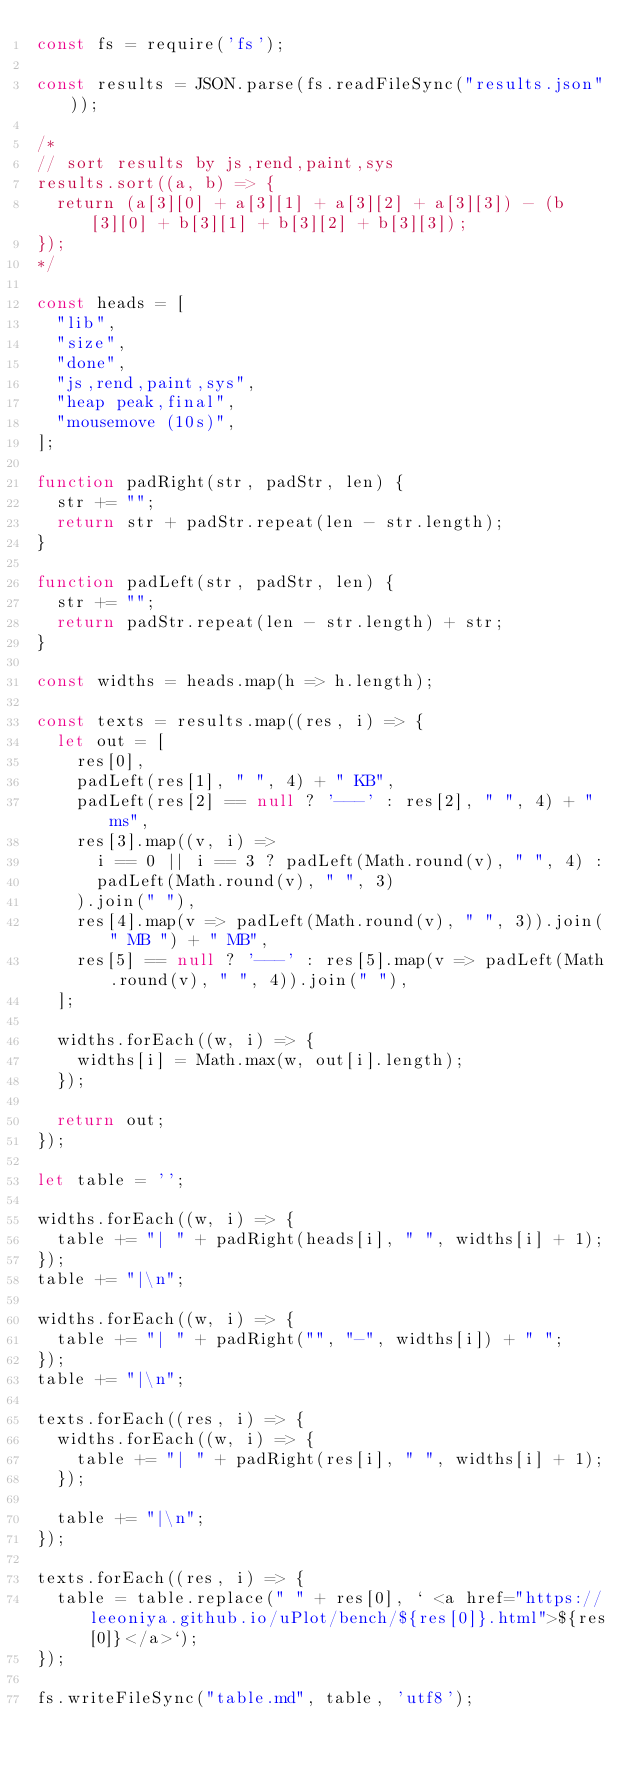Convert code to text. <code><loc_0><loc_0><loc_500><loc_500><_JavaScript_>const fs = require('fs');

const results = JSON.parse(fs.readFileSync("results.json"));

/*
// sort results by js,rend,paint,sys
results.sort((a, b) => {
	return (a[3][0] + a[3][1] + a[3][2] + a[3][3]) - (b[3][0] + b[3][1] + b[3][2] + b[3][3]);
});
*/

const heads = [
	"lib",
	"size",
	"done",
	"js,rend,paint,sys",
	"heap peak,final",
	"mousemove (10s)",
];

function padRight(str, padStr, len) {
	str += "";
	return str + padStr.repeat(len - str.length);
}

function padLeft(str, padStr, len) {
	str += "";
	return padStr.repeat(len - str.length) + str;
}

const widths = heads.map(h => h.length);

const texts = results.map((res, i) => {
	let out = [
		res[0],
		padLeft(res[1], " ", 4) + " KB",
		padLeft(res[2] == null ? '---' : res[2], " ", 4) + " ms",
		res[3].map((v, i) =>
			i == 0 || i == 3 ? padLeft(Math.round(v), " ", 4) :
			padLeft(Math.round(v), " ", 3)
		).join(" "),
		res[4].map(v => padLeft(Math.round(v), " ", 3)).join(" MB ") + " MB",
		res[5] == null ? '---' : res[5].map(v => padLeft(Math.round(v), " ", 4)).join(" "),
	];

	widths.forEach((w, i) => {
		widths[i] = Math.max(w, out[i].length);
	});

	return out;
});

let table = '';

widths.forEach((w, i) => {
	table += "| " + padRight(heads[i], " ", widths[i] + 1);
});
table += "|\n";

widths.forEach((w, i) => {
	table += "| " + padRight("", "-", widths[i]) + " ";
});
table += "|\n";

texts.forEach((res, i) => {
	widths.forEach((w, i) => {
		table += "| " + padRight(res[i], " ", widths[i] + 1);
	});

	table += "|\n";
});

texts.forEach((res, i) => {
	table = table.replace(" " + res[0], ` <a href="https://leeoniya.github.io/uPlot/bench/${res[0]}.html">${res[0]}</a>`);
});

fs.writeFileSync("table.md", table, 'utf8');</code> 